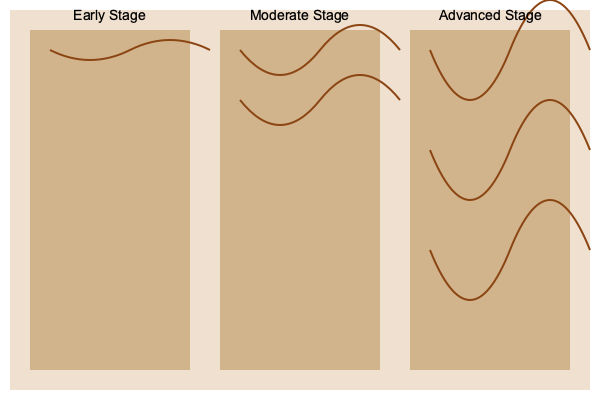Based on the wood damage patterns shown in the image, which stage of termite infestation is represented by the middle section? To identify the different stages of termite infestation using wood damage images, we need to analyze the extent and pattern of the damage:

1. Early Stage:
   - Characterized by minimal visible damage
   - Few shallow tunnels or grooves on the wood surface
   - Represented by the left section in the image

2. Moderate Stage:
   - More extensive damage compared to the early stage
   - Multiple visible tunnels or grooves, but not covering the entire wood surface
   - Wood structure still largely intact
   - Represented by the middle section in the image

3. Advanced Stage:
   - Severe and extensive damage
   - Numerous tunnels and grooves covering most of the wood surface
   - Wood structure significantly compromised
   - Represented by the right section in the image

The middle section shows multiple tunnels or grooves that are more extensive than the early stage but not as severe as the advanced stage. This pattern is consistent with the moderate stage of termite infestation.
Answer: Moderate Stage 